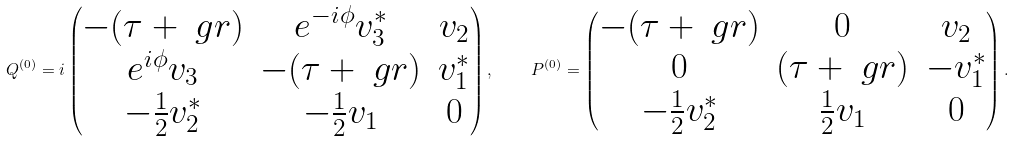<formula> <loc_0><loc_0><loc_500><loc_500>Q ^ { ( 0 ) } = i \begin{pmatrix} - ( \tau + \ g r ) & e ^ { - i \phi } v _ { 3 } ^ { * } & v _ { 2 } \\ e ^ { i \phi } v _ { 3 } & - ( \tau + \ g r ) & v _ { 1 } ^ { * } \\ - \frac { 1 } { 2 } v _ { 2 } ^ { * } & - \frac { 1 } { 2 } v _ { 1 } & 0 \end{pmatrix} , \quad P ^ { ( 0 ) } = \begin{pmatrix} - ( \tau + \ g r ) & 0 & v _ { 2 } \\ 0 & ( \tau + \ g r ) & - v _ { 1 } ^ { * } \\ - \frac { 1 } { 2 } v _ { 2 } ^ { * } & \frac { 1 } { 2 } v _ { 1 } & 0 \end{pmatrix} .</formula> 